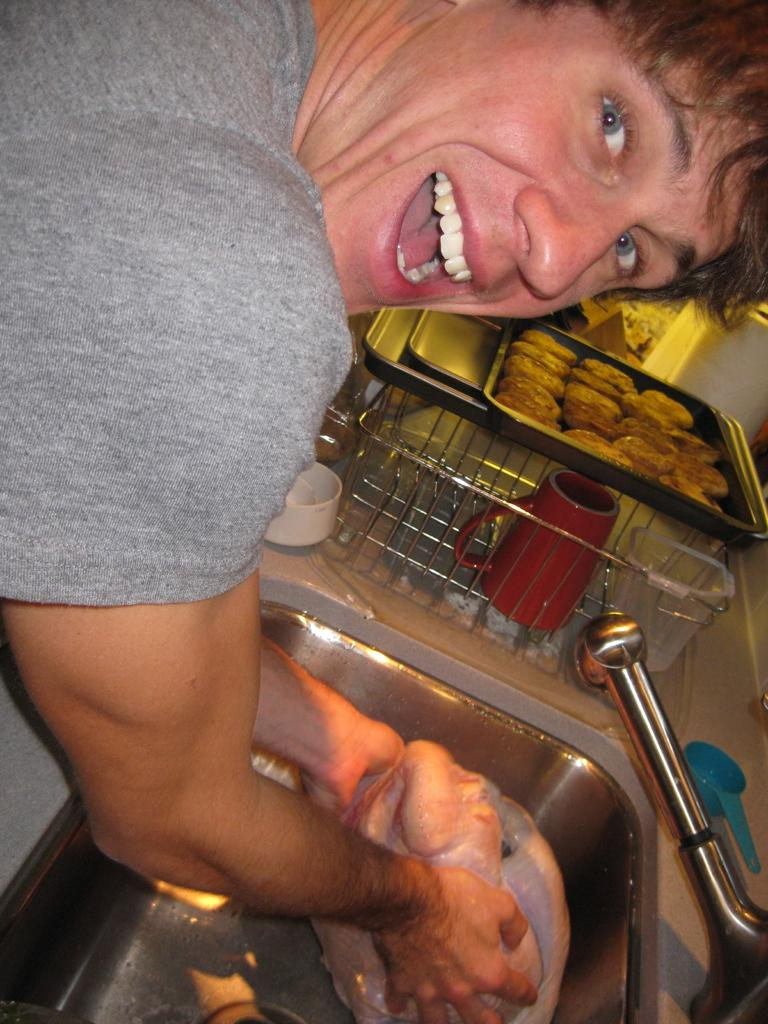Who is present in the image? There is a man in the image. What is the man holding in the image? The man is holding meat. What can be seen near the man in the image? There is a tap and a stainless steel wash basin in the image. What other items are visible in the image? There is a cup, a spoon, and other objects in the image. What is the purpose of the tray in the image? There is food in a tray in the image. What type of rabbit can be seen downtown in the image? There is no rabbit or downtown location present in the image. What is the man's reaction to the surprise in the image? There is no surprise or reaction mentioned in the image. 